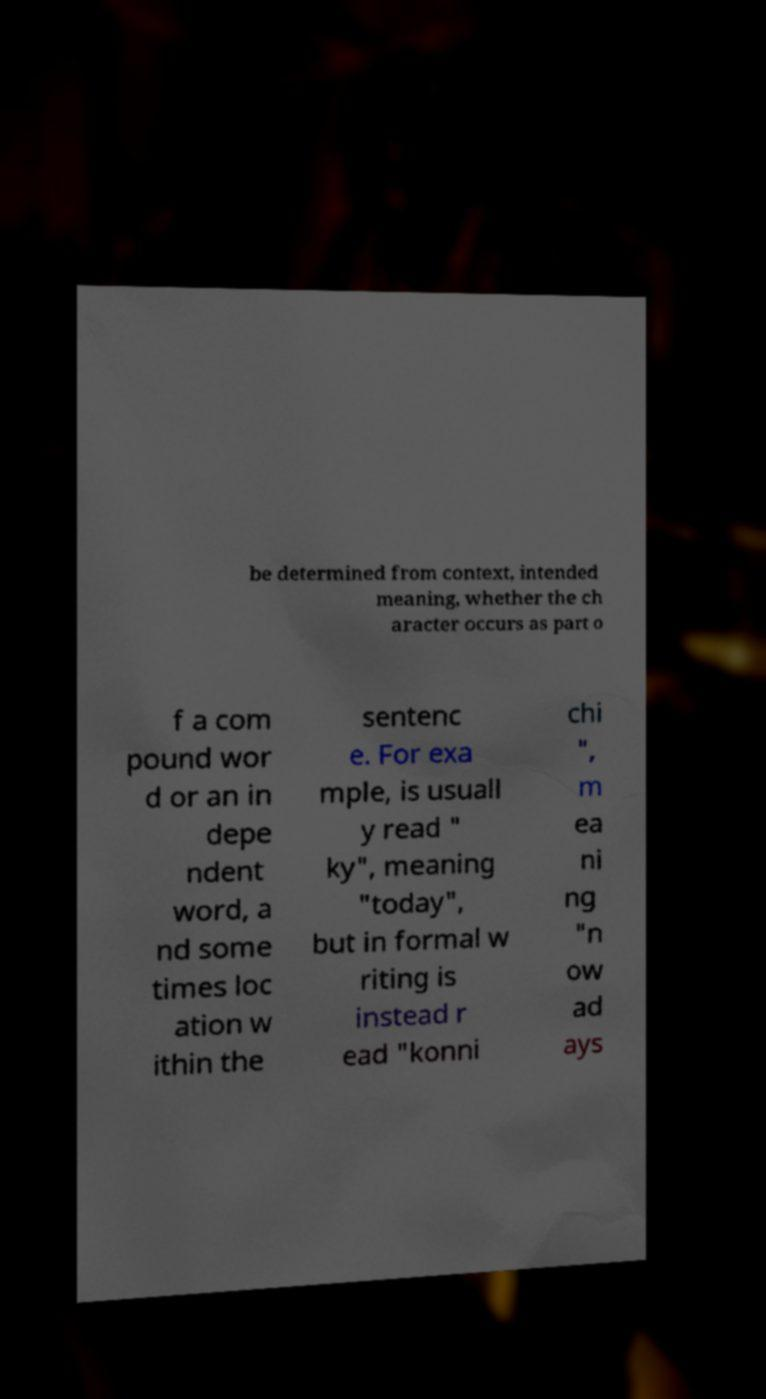Please read and relay the text visible in this image. What does it say? be determined from context, intended meaning, whether the ch aracter occurs as part o f a com pound wor d or an in depe ndent word, a nd some times loc ation w ithin the sentenc e. For exa mple, is usuall y read " ky", meaning "today", but in formal w riting is instead r ead "konni chi ", m ea ni ng "n ow ad ays 